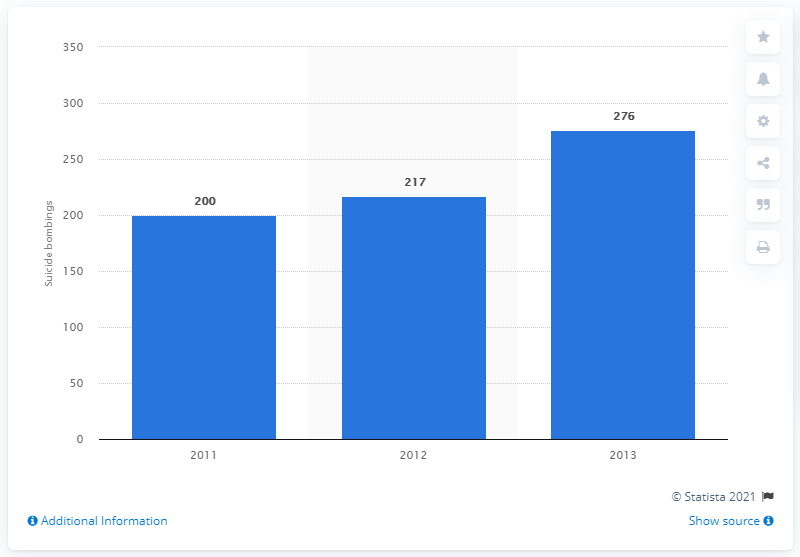Point out several critical features in this image. There were 200 suicide bombings between 2011 and 2013. 